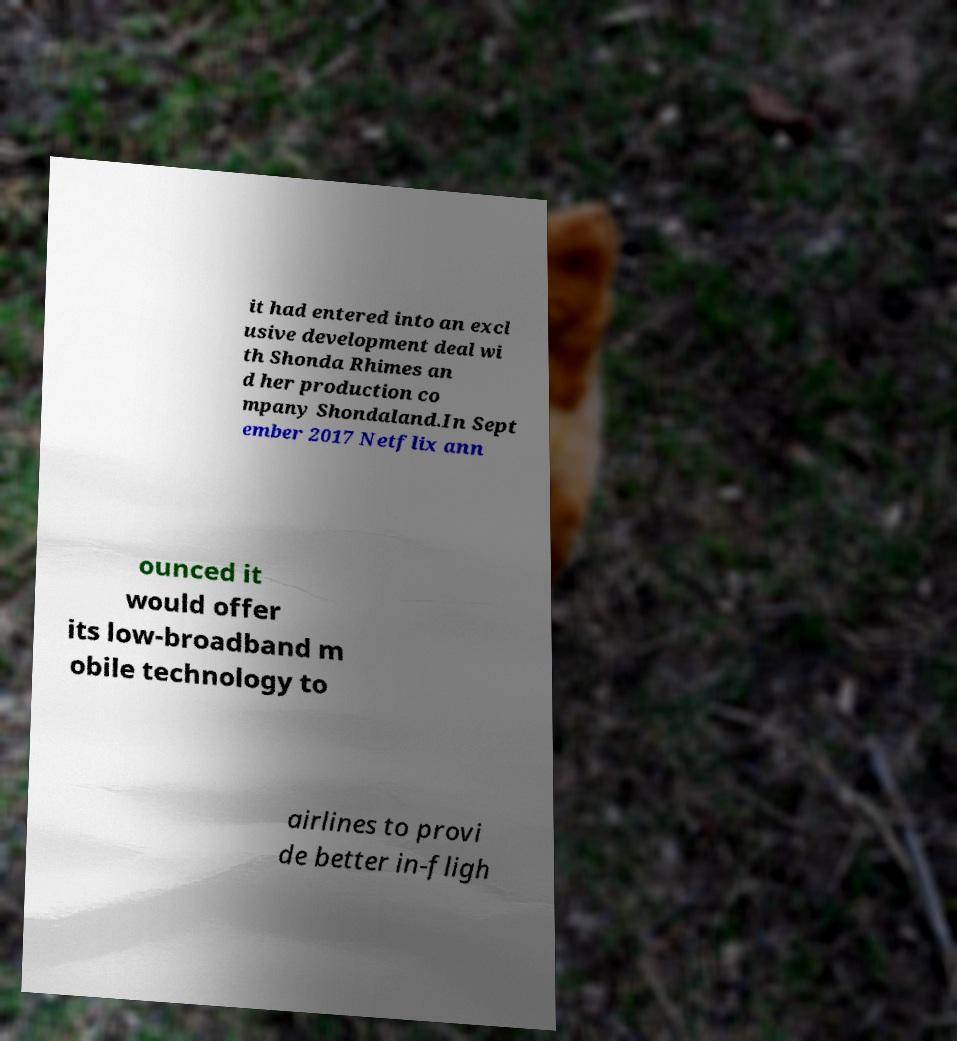There's text embedded in this image that I need extracted. Can you transcribe it verbatim? it had entered into an excl usive development deal wi th Shonda Rhimes an d her production co mpany Shondaland.In Sept ember 2017 Netflix ann ounced it would offer its low-broadband m obile technology to airlines to provi de better in-fligh 